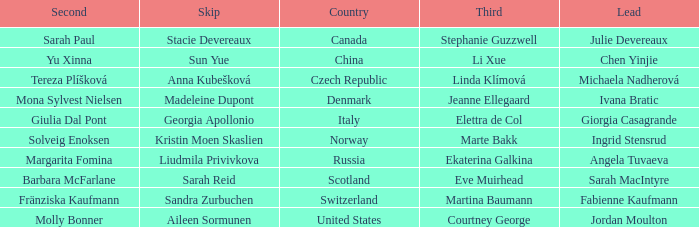What skip has martina baumann as the third? Sandra Zurbuchen. 